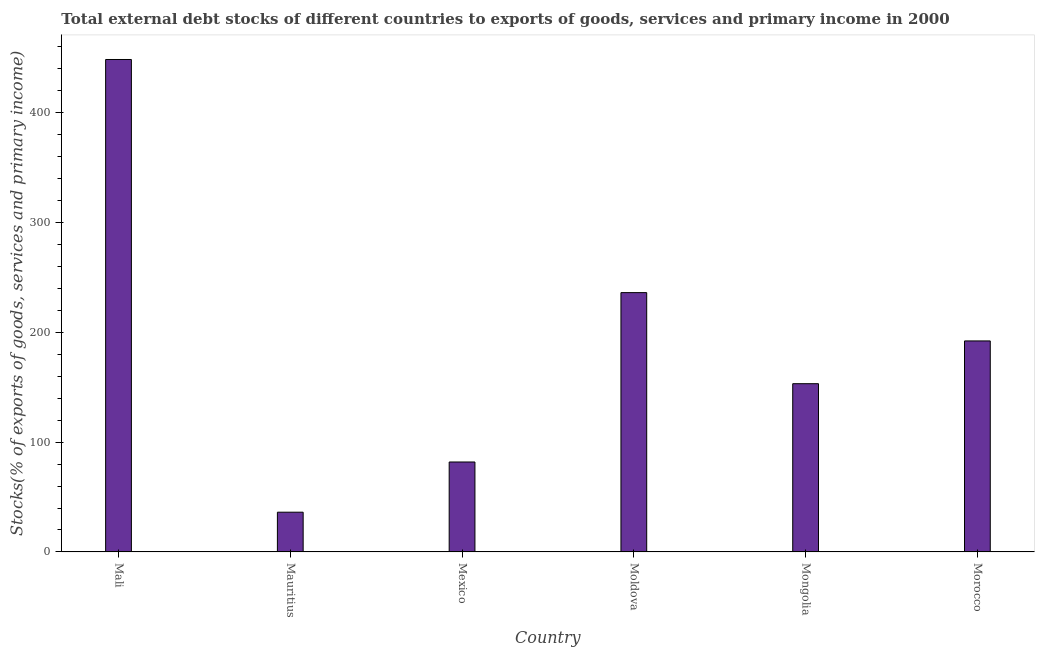Does the graph contain any zero values?
Keep it short and to the point. No. Does the graph contain grids?
Offer a very short reply. No. What is the title of the graph?
Your response must be concise. Total external debt stocks of different countries to exports of goods, services and primary income in 2000. What is the label or title of the Y-axis?
Your response must be concise. Stocks(% of exports of goods, services and primary income). What is the external debt stocks in Mali?
Keep it short and to the point. 448.47. Across all countries, what is the maximum external debt stocks?
Make the answer very short. 448.47. Across all countries, what is the minimum external debt stocks?
Offer a very short reply. 36.19. In which country was the external debt stocks maximum?
Provide a succinct answer. Mali. In which country was the external debt stocks minimum?
Offer a terse response. Mauritius. What is the sum of the external debt stocks?
Offer a very short reply. 1148.16. What is the difference between the external debt stocks in Mexico and Mongolia?
Make the answer very short. -71.3. What is the average external debt stocks per country?
Offer a very short reply. 191.36. What is the median external debt stocks?
Provide a short and direct response. 172.7. What is the ratio of the external debt stocks in Mauritius to that in Morocco?
Provide a short and direct response. 0.19. What is the difference between the highest and the second highest external debt stocks?
Offer a very short reply. 212.31. What is the difference between the highest and the lowest external debt stocks?
Offer a terse response. 412.28. How many bars are there?
Offer a very short reply. 6. Are all the bars in the graph horizontal?
Give a very brief answer. No. How many countries are there in the graph?
Ensure brevity in your answer.  6. Are the values on the major ticks of Y-axis written in scientific E-notation?
Give a very brief answer. No. What is the Stocks(% of exports of goods, services and primary income) in Mali?
Give a very brief answer. 448.47. What is the Stocks(% of exports of goods, services and primary income) in Mauritius?
Offer a terse response. 36.19. What is the Stocks(% of exports of goods, services and primary income) in Mexico?
Provide a succinct answer. 81.93. What is the Stocks(% of exports of goods, services and primary income) in Moldova?
Your response must be concise. 236.17. What is the Stocks(% of exports of goods, services and primary income) of Mongolia?
Your answer should be very brief. 153.23. What is the Stocks(% of exports of goods, services and primary income) of Morocco?
Make the answer very short. 192.17. What is the difference between the Stocks(% of exports of goods, services and primary income) in Mali and Mauritius?
Your response must be concise. 412.28. What is the difference between the Stocks(% of exports of goods, services and primary income) in Mali and Mexico?
Your response must be concise. 366.55. What is the difference between the Stocks(% of exports of goods, services and primary income) in Mali and Moldova?
Your answer should be very brief. 212.31. What is the difference between the Stocks(% of exports of goods, services and primary income) in Mali and Mongolia?
Provide a succinct answer. 295.24. What is the difference between the Stocks(% of exports of goods, services and primary income) in Mali and Morocco?
Make the answer very short. 256.3. What is the difference between the Stocks(% of exports of goods, services and primary income) in Mauritius and Mexico?
Keep it short and to the point. -45.73. What is the difference between the Stocks(% of exports of goods, services and primary income) in Mauritius and Moldova?
Provide a succinct answer. -199.97. What is the difference between the Stocks(% of exports of goods, services and primary income) in Mauritius and Mongolia?
Give a very brief answer. -117.03. What is the difference between the Stocks(% of exports of goods, services and primary income) in Mauritius and Morocco?
Offer a terse response. -155.98. What is the difference between the Stocks(% of exports of goods, services and primary income) in Mexico and Moldova?
Give a very brief answer. -154.24. What is the difference between the Stocks(% of exports of goods, services and primary income) in Mexico and Mongolia?
Give a very brief answer. -71.3. What is the difference between the Stocks(% of exports of goods, services and primary income) in Mexico and Morocco?
Your answer should be compact. -110.25. What is the difference between the Stocks(% of exports of goods, services and primary income) in Moldova and Mongolia?
Make the answer very short. 82.94. What is the difference between the Stocks(% of exports of goods, services and primary income) in Moldova and Morocco?
Ensure brevity in your answer.  43.99. What is the difference between the Stocks(% of exports of goods, services and primary income) in Mongolia and Morocco?
Provide a succinct answer. -38.95. What is the ratio of the Stocks(% of exports of goods, services and primary income) in Mali to that in Mauritius?
Provide a succinct answer. 12.39. What is the ratio of the Stocks(% of exports of goods, services and primary income) in Mali to that in Mexico?
Give a very brief answer. 5.47. What is the ratio of the Stocks(% of exports of goods, services and primary income) in Mali to that in Moldova?
Keep it short and to the point. 1.9. What is the ratio of the Stocks(% of exports of goods, services and primary income) in Mali to that in Mongolia?
Your answer should be compact. 2.93. What is the ratio of the Stocks(% of exports of goods, services and primary income) in Mali to that in Morocco?
Offer a terse response. 2.33. What is the ratio of the Stocks(% of exports of goods, services and primary income) in Mauritius to that in Mexico?
Your answer should be very brief. 0.44. What is the ratio of the Stocks(% of exports of goods, services and primary income) in Mauritius to that in Moldova?
Offer a terse response. 0.15. What is the ratio of the Stocks(% of exports of goods, services and primary income) in Mauritius to that in Mongolia?
Provide a succinct answer. 0.24. What is the ratio of the Stocks(% of exports of goods, services and primary income) in Mauritius to that in Morocco?
Offer a very short reply. 0.19. What is the ratio of the Stocks(% of exports of goods, services and primary income) in Mexico to that in Moldova?
Give a very brief answer. 0.35. What is the ratio of the Stocks(% of exports of goods, services and primary income) in Mexico to that in Mongolia?
Offer a very short reply. 0.54. What is the ratio of the Stocks(% of exports of goods, services and primary income) in Mexico to that in Morocco?
Keep it short and to the point. 0.43. What is the ratio of the Stocks(% of exports of goods, services and primary income) in Moldova to that in Mongolia?
Ensure brevity in your answer.  1.54. What is the ratio of the Stocks(% of exports of goods, services and primary income) in Moldova to that in Morocco?
Your answer should be compact. 1.23. What is the ratio of the Stocks(% of exports of goods, services and primary income) in Mongolia to that in Morocco?
Make the answer very short. 0.8. 